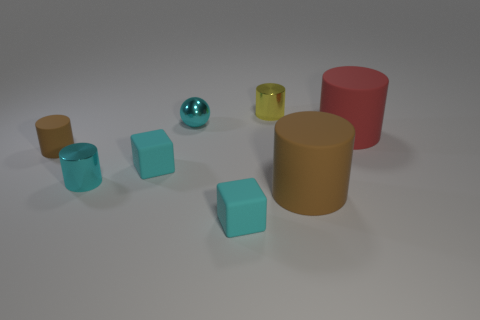Subtract all small yellow metallic cylinders. How many cylinders are left? 4 Add 1 tiny red metallic things. How many objects exist? 9 Subtract all cyan cylinders. How many cylinders are left? 4 Subtract 1 blocks. How many blocks are left? 1 Subtract all balls. How many objects are left? 7 Subtract all blue cylinders. How many green blocks are left? 0 Subtract all tiny metal objects. Subtract all yellow shiny cylinders. How many objects are left? 4 Add 4 cyan shiny cylinders. How many cyan shiny cylinders are left? 5 Add 2 small yellow objects. How many small yellow objects exist? 3 Subtract 0 green spheres. How many objects are left? 8 